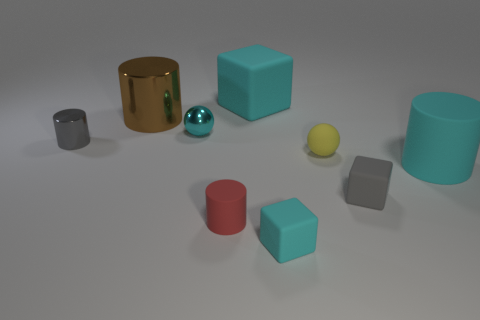Add 1 tiny purple blocks. How many objects exist? 10 Subtract all cylinders. How many objects are left? 5 Subtract all yellow matte spheres. Subtract all big rubber cylinders. How many objects are left? 7 Add 6 small gray rubber cubes. How many small gray rubber cubes are left? 7 Add 3 red rubber objects. How many red rubber objects exist? 4 Subtract 0 brown spheres. How many objects are left? 9 